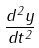Convert formula to latex. <formula><loc_0><loc_0><loc_500><loc_500>\frac { d ^ { 2 } y } { d t ^ { 2 } }</formula> 